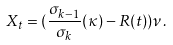Convert formula to latex. <formula><loc_0><loc_0><loc_500><loc_500>X _ { t } = ( \frac { \sigma _ { k - 1 } } { \sigma _ { k } } ( \kappa ) - R ( t ) ) \nu .</formula> 